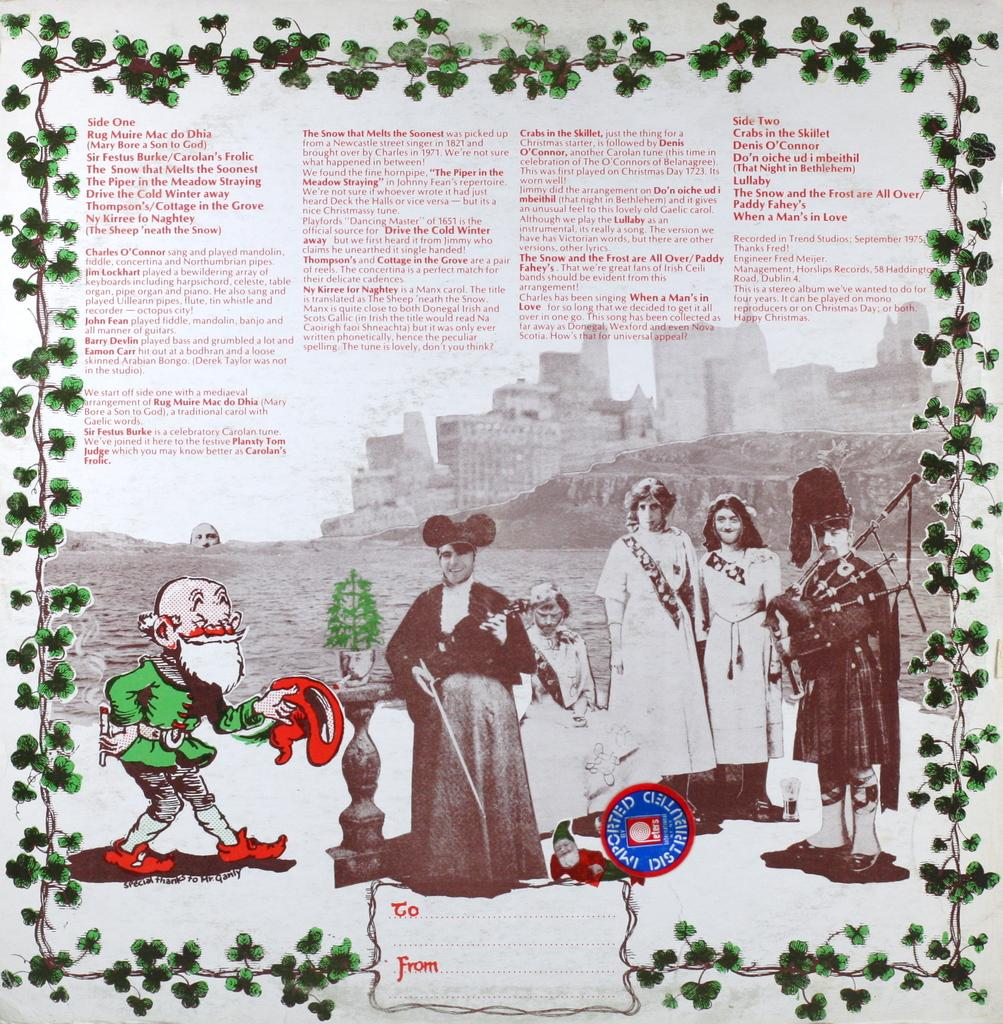What is present on the paper in the image? There is writing on the paper, as well as pictures of persons and cartoon characters. Can you describe the design around the paper? There is a design of leaves around the paper. What type of army is depicted in the image? There is no army present in the image; it features a paper with writing and pictures of persons and cartoon characters. How many elbows can be seen in the image? There are no elbows visible in the image, as it features a paper with writing and pictures. 